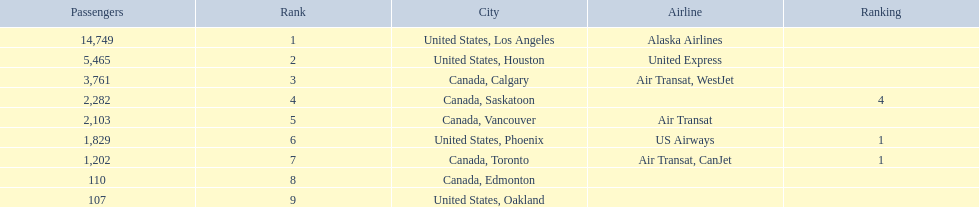Could you parse the entire table as a dict? {'header': ['Passengers', 'Rank', 'City', 'Airline', 'Ranking'], 'rows': [['14,749', '1', 'United States, Los Angeles', 'Alaska Airlines', ''], ['5,465', '2', 'United States, Houston', 'United Express', ''], ['3,761', '3', 'Canada, Calgary', 'Air Transat, WestJet', ''], ['2,282', '4', 'Canada, Saskatoon', '', '4'], ['2,103', '5', 'Canada, Vancouver', 'Air Transat', ''], ['1,829', '6', 'United States, Phoenix', 'US Airways', '1'], ['1,202', '7', 'Canada, Toronto', 'Air Transat, CanJet', '1'], ['110', '8', 'Canada, Edmonton', '', ''], ['107', '9', 'United States, Oakland', '', '']]} What numbers are in the passengers column? 14,749, 5,465, 3,761, 2,282, 2,103, 1,829, 1,202, 110, 107. Which number is the lowest number in the passengers column? 107. What city is associated with this number? United States, Oakland. 